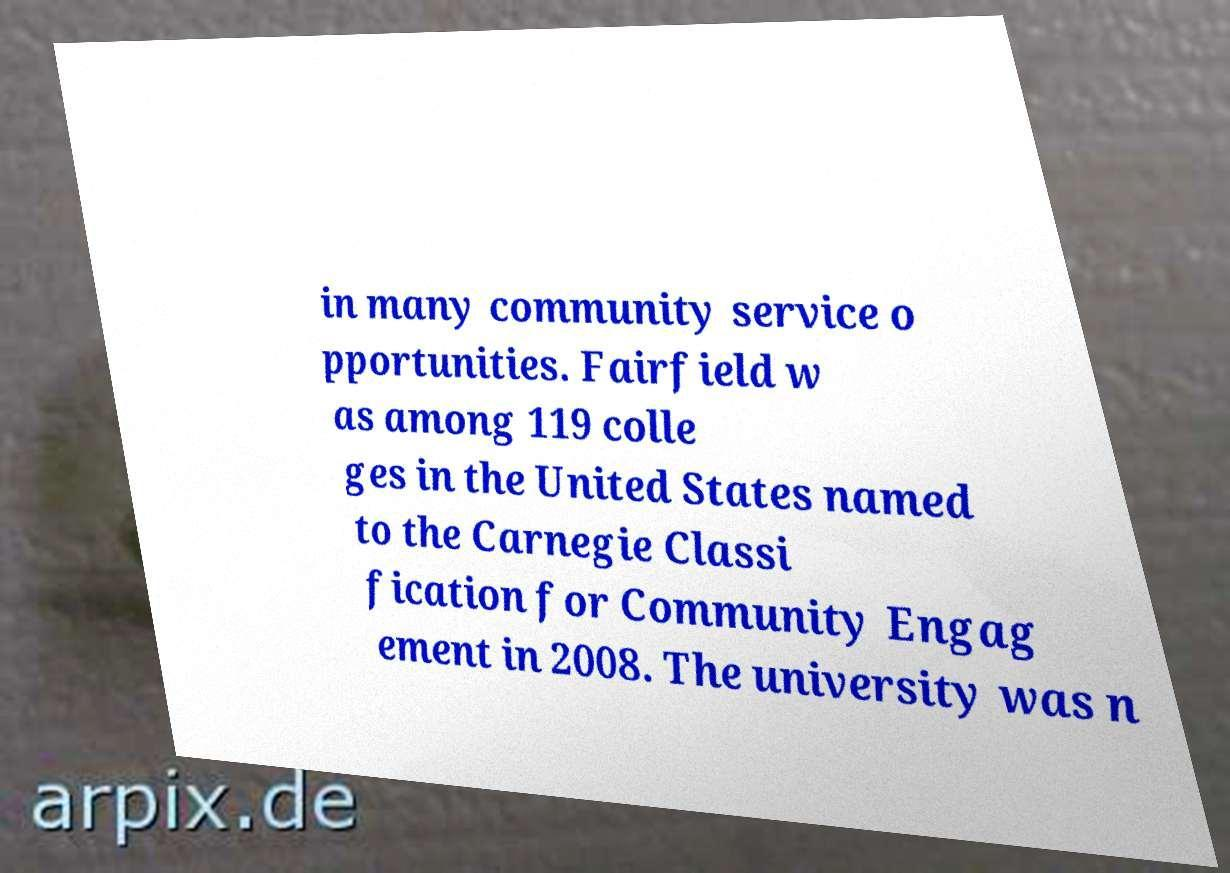There's text embedded in this image that I need extracted. Can you transcribe it verbatim? in many community service o pportunities. Fairfield w as among 119 colle ges in the United States named to the Carnegie Classi fication for Community Engag ement in 2008. The university was n 